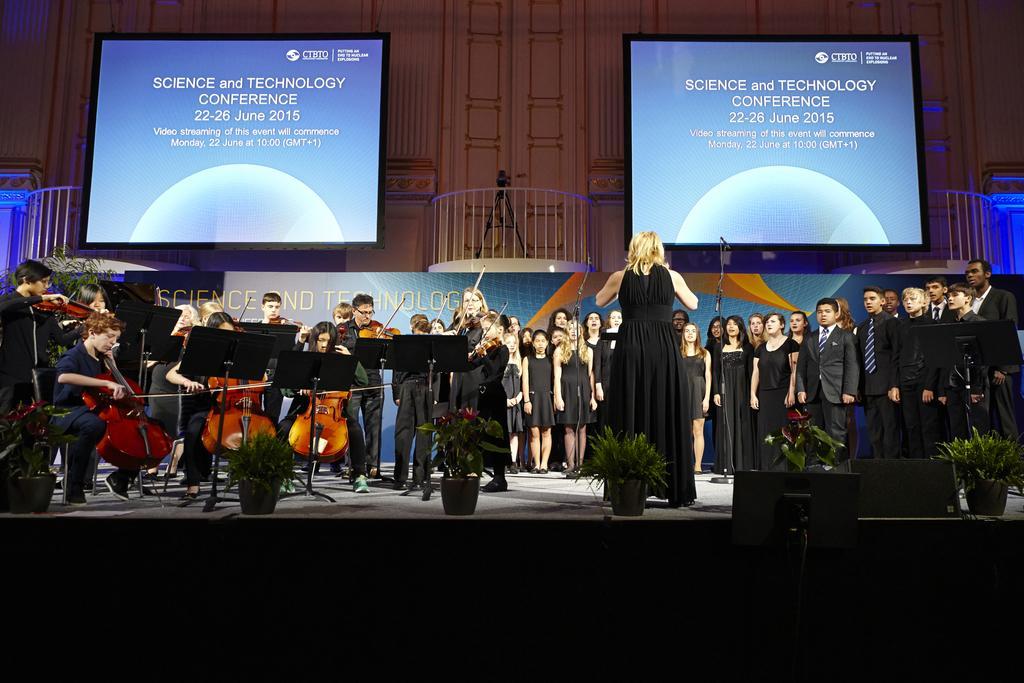How would you summarize this image in a sentence or two? There are people standing and some are sitting on the stage, they are holding guitars in their hands, there are plants in the foreground area of the image. There are screens, poster and stage wall in the background. 